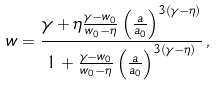Convert formula to latex. <formula><loc_0><loc_0><loc_500><loc_500>w = \frac { \gamma + \eta \frac { \gamma - w _ { 0 } } { w _ { 0 } - \eta } \left ( \frac { a } { a _ { 0 } } \right ) ^ { 3 ( \gamma - \eta ) } } { 1 + \frac { \gamma - w _ { 0 } } { w _ { 0 } - \eta } \left ( \frac { a } { a _ { 0 } } \right ) ^ { 3 ( \gamma - \eta ) } } \, ,</formula> 